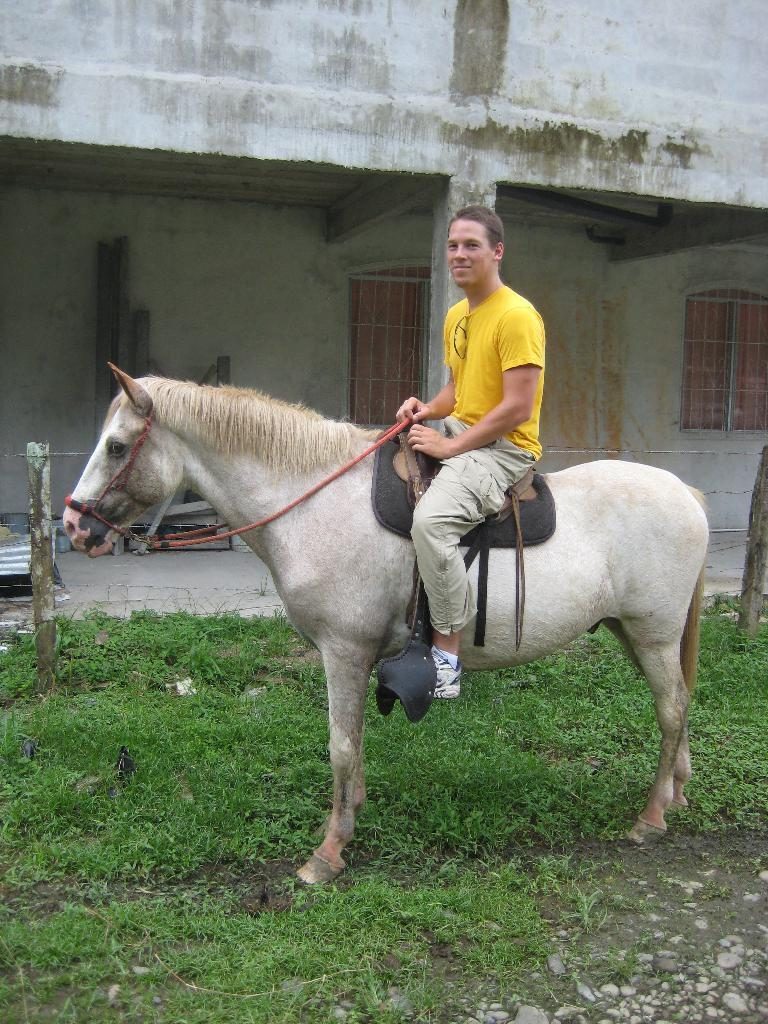Who is present in the image? There is a man in the image. What is the man doing in the image? The man is sitting on a horse. Where is the horse located? The horse is on grass land. What can be seen in the background of the image? There is a building visible in the background. What type of arm is the man using to taste the horse in the image? The man is not tasting the horse in the image, and there is no mention of an arm being used for that purpose. 